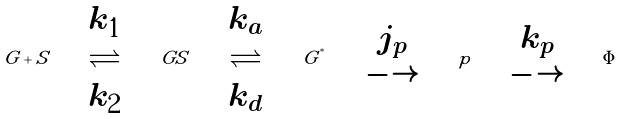Convert formula to latex. <formula><loc_0><loc_0><loc_500><loc_500>G + S \quad \begin{array} { c } k _ { 1 } \\ \rightleftharpoons \\ k _ { 2 } \end{array} \quad G S \quad \begin{array} { c } k _ { a } \\ \rightleftharpoons \\ k _ { d } \end{array} \quad G ^ { ^ { * } } \quad \begin{array} [ b ] { c } j _ { p } \\ \longrightarrow \end{array} \quad p \quad \begin{array} [ b ] { c } k _ { p } \\ \longrightarrow \end{array} \quad \Phi</formula> 